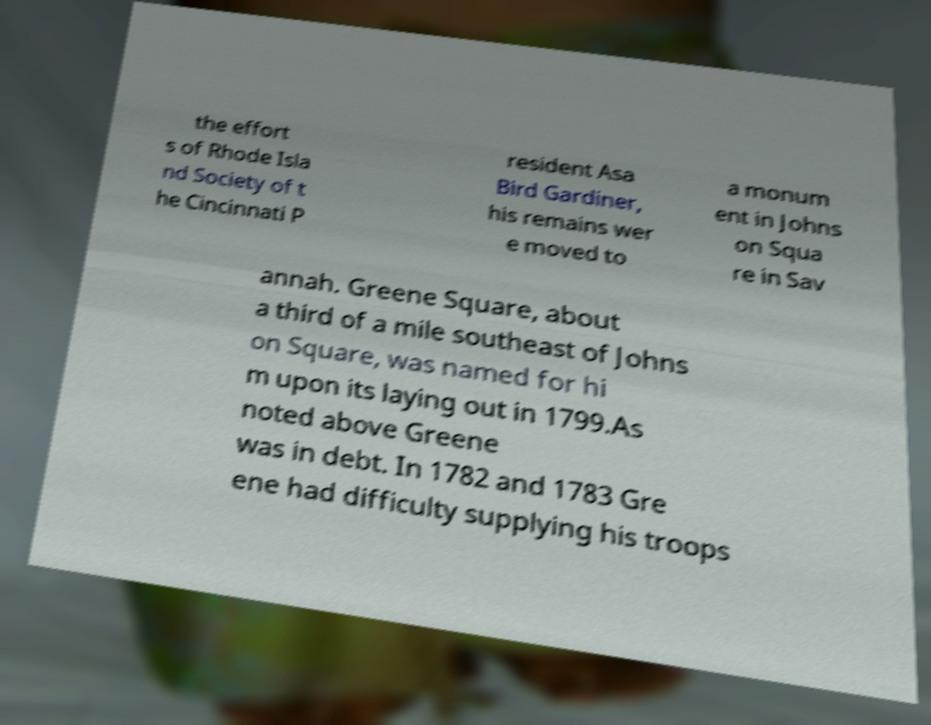Can you read and provide the text displayed in the image?This photo seems to have some interesting text. Can you extract and type it out for me? the effort s of Rhode Isla nd Society of t he Cincinnati P resident Asa Bird Gardiner, his remains wer e moved to a monum ent in Johns on Squa re in Sav annah. Greene Square, about a third of a mile southeast of Johns on Square, was named for hi m upon its laying out in 1799.As noted above Greene was in debt. In 1782 and 1783 Gre ene had difficulty supplying his troops 